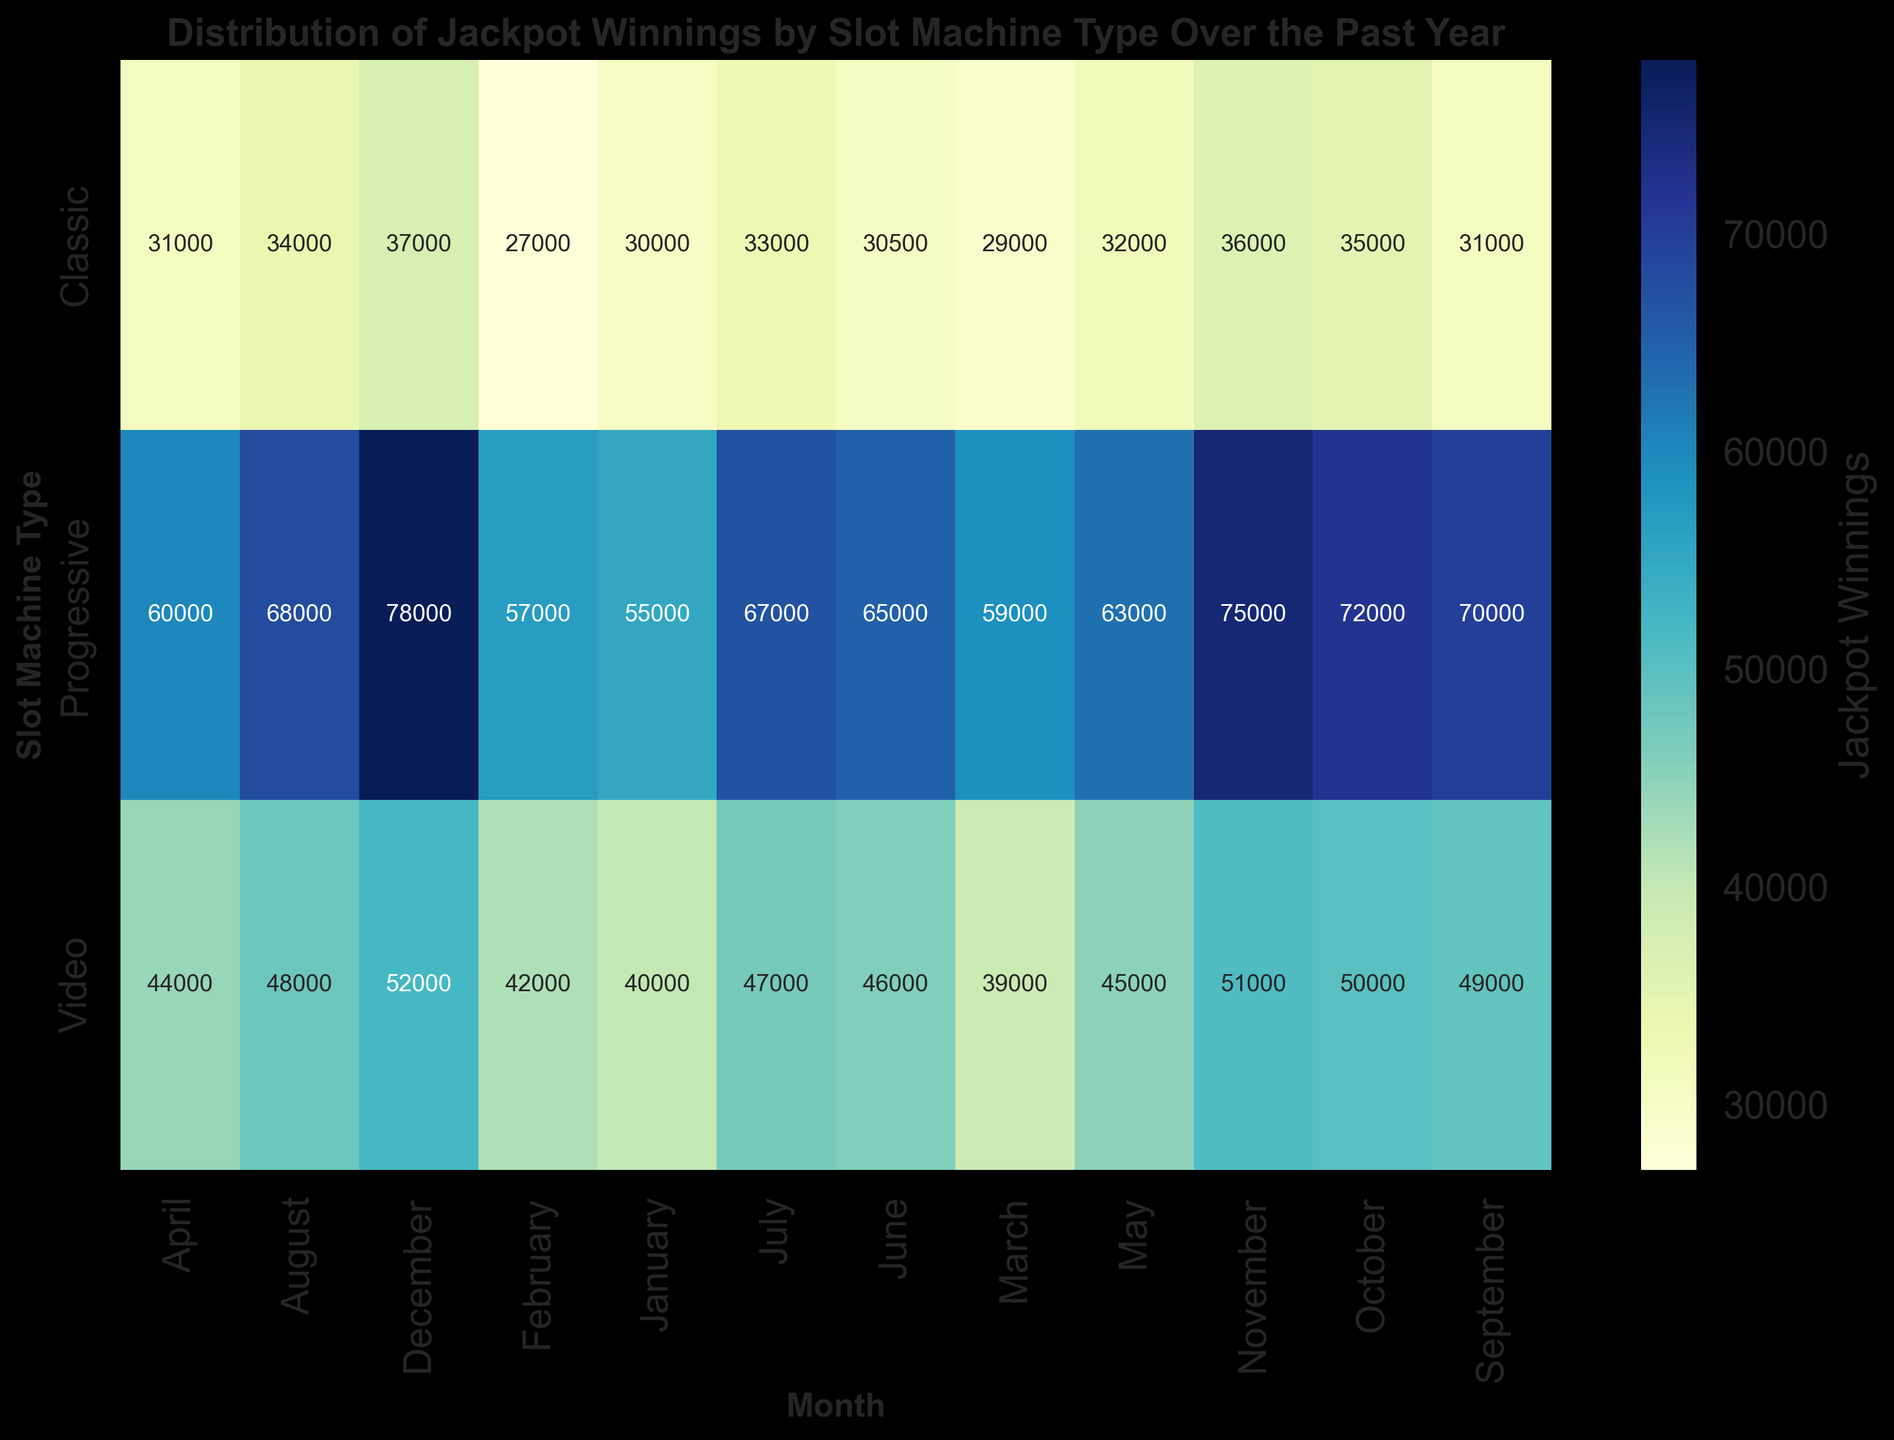Which slot machine type had the highest jackpot winnings in August? Look at all jackpot winnings for August across the different slot machine types. The highest value is 68,000 for the Progressive type.
Answer: Progressive Which month had the highest jackpot winnings for Classic slot machines? Look at the jackpot winnings for Classic slot machines across all months. The highest value is 37,000 in December.
Answer: December What is the total jackpot winnings for the Video slot machines in the first quarter (January to March)? Sum the jackpot winnings for Video slot machines in January, February, and March: 40,000 + 42,000 + 39,000 = 121,000.
Answer: 121,000 Compare the jackpot winnings of Progressive slot machines in June and November. Which one is higher? Look at the values for Progressive slot machines in June (65,000) and November (75,000). The value in November is higher.
Answer: November What is the average jackpot winnings for the Classic slot machines over the year? Sum all the monthly jackpot winnings for Classic slot machines and divide by 12. (30,000 + 27,000 + 29,000 + 31,000 + 32,000 + 30,500 + 33,000 + 34,000 + 31,000 + 35,000 + 36,000 + 37,000) / 12 = 32,125.
Answer: 32,125 Which month shows the smallest difference in jackpot winnings between Classic and Video slot machines? Calculate the absolute differences between Classic and Video slot machines for each month and find the minimum. The differences are: January: 10,000; February: 15,000; March: 10,000; April: 13,000; May: 13,000; June: 15,500; July: 14,000; August: 14,000; September: 18,000; October: 15,000; November: 15,000; December: 15,000. The smallest difference is 10,000 in January and March.
Answer: January, March Which slot machine type shows the most stable (least variance) jackpot winnings over the year? Calculate the variance of the jackpot winnings for Classic, Video, and Progressive slot machines. The one with the smallest variance is the most stable. Classic variance: 17.43M, Video variance: 17.30M, Progressive variance: 48.61M. The Video slot machine has the least variance.
Answer: Video Are there any months where the jackpot winnings for Progressive slot machines exceeded 70,000? Look for any values greater than 70,000 in the jackpot winnings for Progressive slot machines. The months are September (70,000), October (72,000), November (75,000), December (78,000).
Answer: Yes Do the jackpot winnings for any slot machine type show a consistent increase or decrease throughout the year? Observe the trend of jackpot winnings for each slot machine type from January to December. Progressive and Video slot machines show a consistent increase, while Classic shows a less consistent trend.
Answer: Progressive, Video 